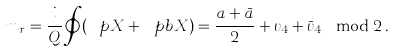<formula> <loc_0><loc_0><loc_500><loc_500>m _ { r } = \frac { i } { Q } \oint ( \ p X + \ p b X ) = \frac { a + \bar { a } } { 2 } + \upsilon _ { 4 } + \bar { \upsilon } _ { 4 } \mod 2 \, .</formula> 